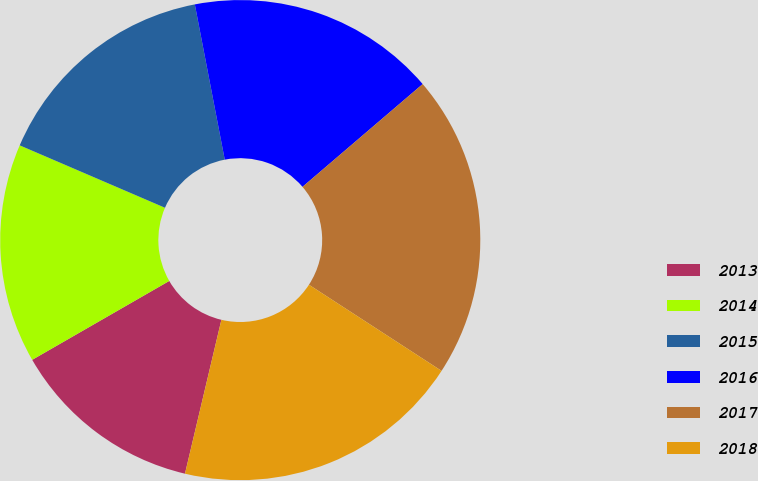Convert chart. <chart><loc_0><loc_0><loc_500><loc_500><pie_chart><fcel>2013<fcel>2014<fcel>2015<fcel>2016<fcel>2017<fcel>2018<nl><fcel>12.99%<fcel>14.77%<fcel>15.51%<fcel>16.77%<fcel>20.43%<fcel>19.53%<nl></chart> 